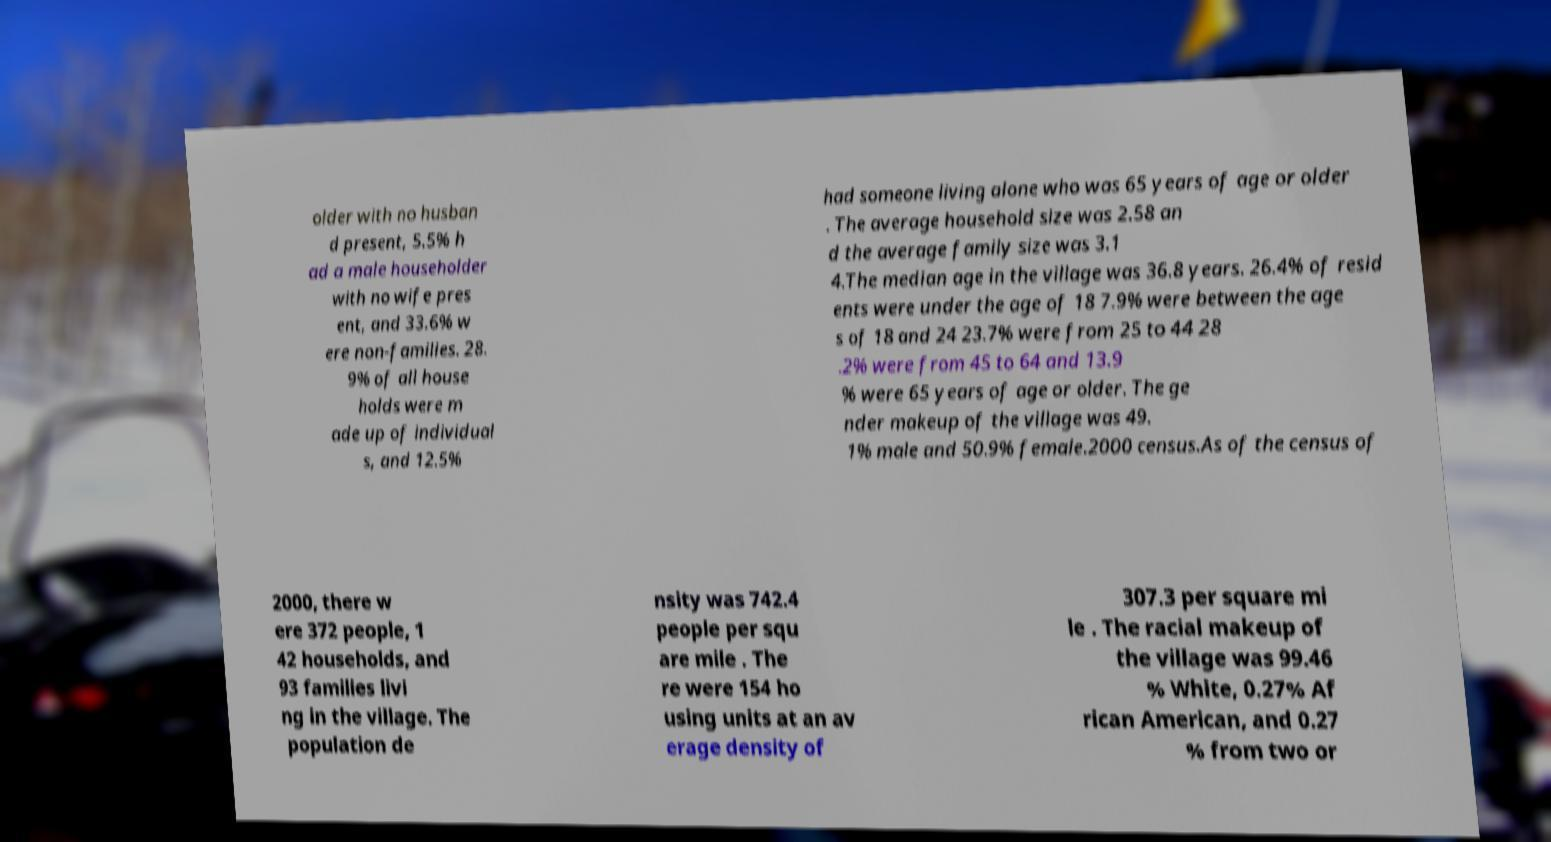Can you read and provide the text displayed in the image?This photo seems to have some interesting text. Can you extract and type it out for me? older with no husban d present, 5.5% h ad a male householder with no wife pres ent, and 33.6% w ere non-families. 28. 9% of all house holds were m ade up of individual s, and 12.5% had someone living alone who was 65 years of age or older . The average household size was 2.58 an d the average family size was 3.1 4.The median age in the village was 36.8 years. 26.4% of resid ents were under the age of 18 7.9% were between the age s of 18 and 24 23.7% were from 25 to 44 28 .2% were from 45 to 64 and 13.9 % were 65 years of age or older. The ge nder makeup of the village was 49. 1% male and 50.9% female.2000 census.As of the census of 2000, there w ere 372 people, 1 42 households, and 93 families livi ng in the village. The population de nsity was 742.4 people per squ are mile . The re were 154 ho using units at an av erage density of 307.3 per square mi le . The racial makeup of the village was 99.46 % White, 0.27% Af rican American, and 0.27 % from two or 